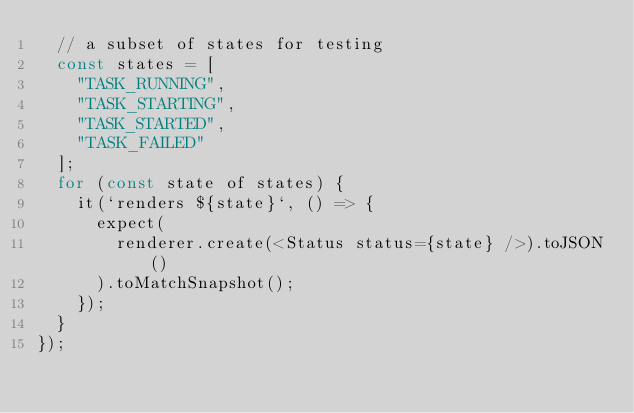<code> <loc_0><loc_0><loc_500><loc_500><_JavaScript_>  // a subset of states for testing
  const states = [
    "TASK_RUNNING",
    "TASK_STARTING",
    "TASK_STARTED",
    "TASK_FAILED"
  ];
  for (const state of states) {
    it(`renders ${state}`, () => {
      expect(
        renderer.create(<Status status={state} />).toJSON()
      ).toMatchSnapshot();
    });
  }
});
</code> 